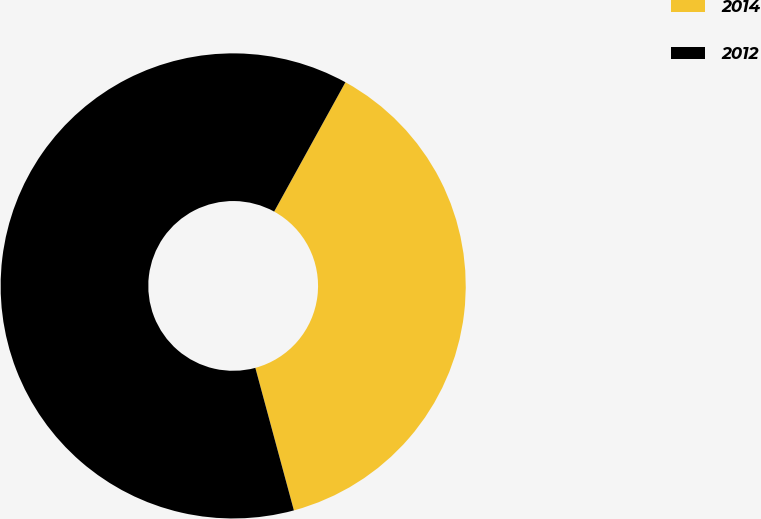Convert chart to OTSL. <chart><loc_0><loc_0><loc_500><loc_500><pie_chart><fcel>2014<fcel>2012<nl><fcel>37.78%<fcel>62.22%<nl></chart> 